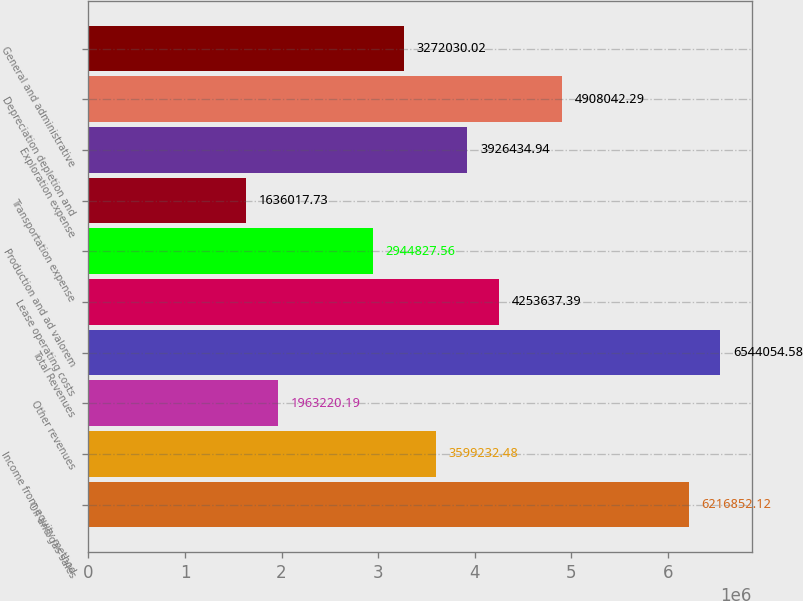Convert chart. <chart><loc_0><loc_0><loc_500><loc_500><bar_chart><fcel>Oil and gas sales<fcel>Income from equity method<fcel>Other revenues<fcel>Total Revenues<fcel>Lease operating costs<fcel>Production and ad valorem<fcel>Transportation expense<fcel>Exploration expense<fcel>Depreciation depletion and<fcel>General and administrative<nl><fcel>6.21685e+06<fcel>3.59923e+06<fcel>1.96322e+06<fcel>6.54405e+06<fcel>4.25364e+06<fcel>2.94483e+06<fcel>1.63602e+06<fcel>3.92643e+06<fcel>4.90804e+06<fcel>3.27203e+06<nl></chart> 